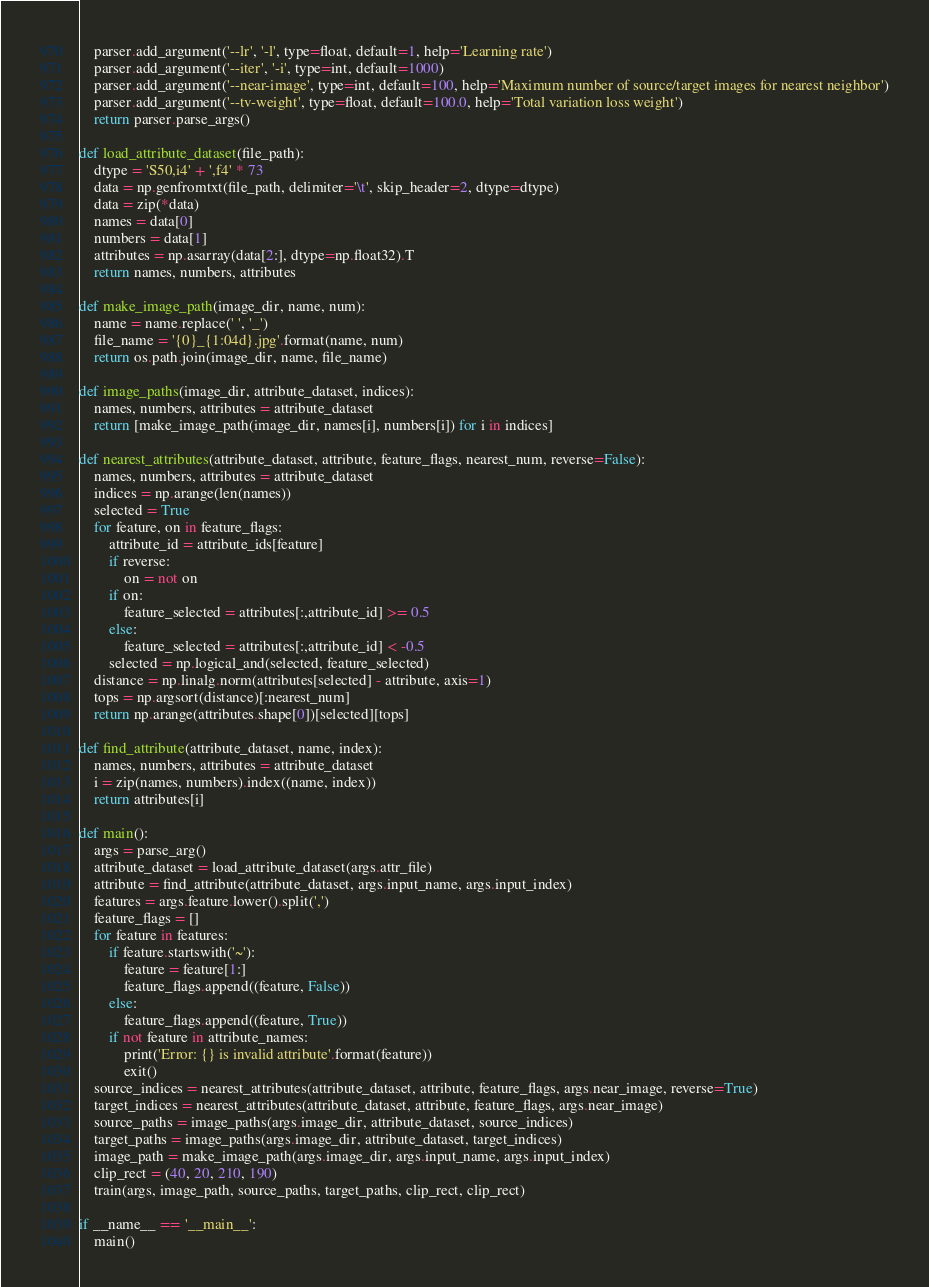<code> <loc_0><loc_0><loc_500><loc_500><_Python_>    parser.add_argument('--lr', '-l', type=float, default=1, help='Learning rate')
    parser.add_argument('--iter', '-i', type=int, default=1000)
    parser.add_argument('--near-image', type=int, default=100, help='Maximum number of source/target images for nearest neighbor')
    parser.add_argument('--tv-weight', type=float, default=100.0, help='Total variation loss weight')
    return parser.parse_args()

def load_attribute_dataset(file_path):
    dtype = 'S50,i4' + ',f4' * 73
    data = np.genfromtxt(file_path, delimiter='\t', skip_header=2, dtype=dtype)
    data = zip(*data)
    names = data[0]
    numbers = data[1]
    attributes = np.asarray(data[2:], dtype=np.float32).T
    return names, numbers, attributes

def make_image_path(image_dir, name, num):
    name = name.replace(' ', '_')
    file_name = '{0}_{1:04d}.jpg'.format(name, num)
    return os.path.join(image_dir, name, file_name)

def image_paths(image_dir, attribute_dataset, indices):
    names, numbers, attributes = attribute_dataset
    return [make_image_path(image_dir, names[i], numbers[i]) for i in indices]

def nearest_attributes(attribute_dataset, attribute, feature_flags, nearest_num, reverse=False):
    names, numbers, attributes = attribute_dataset
    indices = np.arange(len(names))
    selected = True
    for feature, on in feature_flags:
        attribute_id = attribute_ids[feature]
        if reverse:
            on = not on
        if on:
            feature_selected = attributes[:,attribute_id] >= 0.5
        else:
            feature_selected = attributes[:,attribute_id] < -0.5
        selected = np.logical_and(selected, feature_selected)
    distance = np.linalg.norm(attributes[selected] - attribute, axis=1)
    tops = np.argsort(distance)[:nearest_num]
    return np.arange(attributes.shape[0])[selected][tops]

def find_attribute(attribute_dataset, name, index):
    names, numbers, attributes = attribute_dataset
    i = zip(names, numbers).index((name, index))
    return attributes[i]

def main():
    args = parse_arg()
    attribute_dataset = load_attribute_dataset(args.attr_file)
    attribute = find_attribute(attribute_dataset, args.input_name, args.input_index)
    features = args.feature.lower().split(',')
    feature_flags = []
    for feature in features:
        if feature.startswith('~'):
            feature = feature[1:]
            feature_flags.append((feature, False))
        else:
            feature_flags.append((feature, True))
        if not feature in attribute_names:
            print('Error: {} is invalid attribute'.format(feature))
            exit()
    source_indices = nearest_attributes(attribute_dataset, attribute, feature_flags, args.near_image, reverse=True)
    target_indices = nearest_attributes(attribute_dataset, attribute, feature_flags, args.near_image)
    source_paths = image_paths(args.image_dir, attribute_dataset, source_indices)
    target_paths = image_paths(args.image_dir, attribute_dataset, target_indices)
    image_path = make_image_path(args.image_dir, args.input_name, args.input_index)
    clip_rect = (40, 20, 210, 190)
    train(args, image_path, source_paths, target_paths, clip_rect, clip_rect)

if __name__ == '__main__':
    main()
</code> 